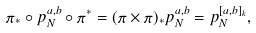Convert formula to latex. <formula><loc_0><loc_0><loc_500><loc_500>\pi _ { * } \circ p _ { N } ^ { a , b } \circ \pi ^ { * } = ( \pi \times \pi ) _ { * } p _ { N } ^ { a , b } = p _ { N } ^ { [ a , b ] _ { k } } ,</formula> 